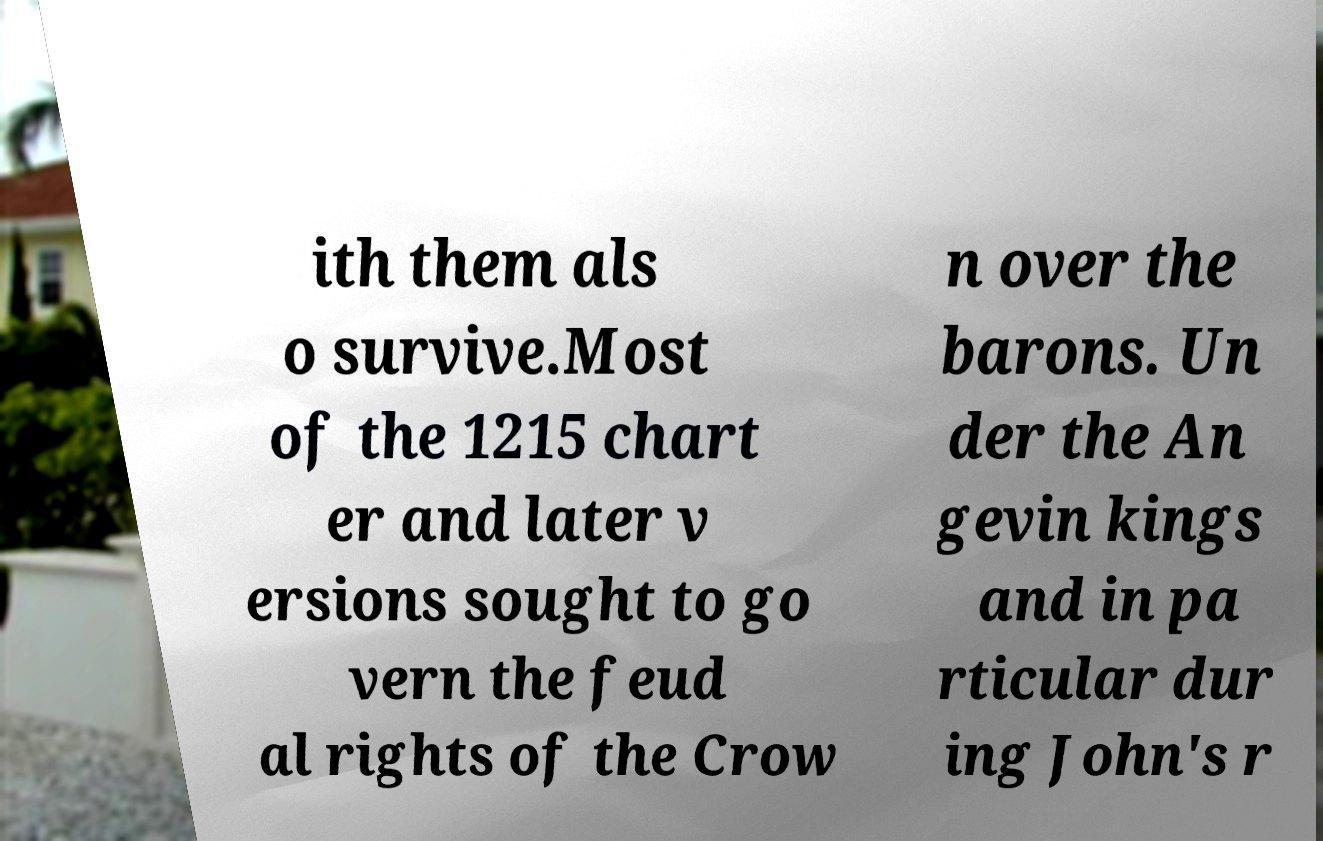Could you extract and type out the text from this image? ith them als o survive.Most of the 1215 chart er and later v ersions sought to go vern the feud al rights of the Crow n over the barons. Un der the An gevin kings and in pa rticular dur ing John's r 